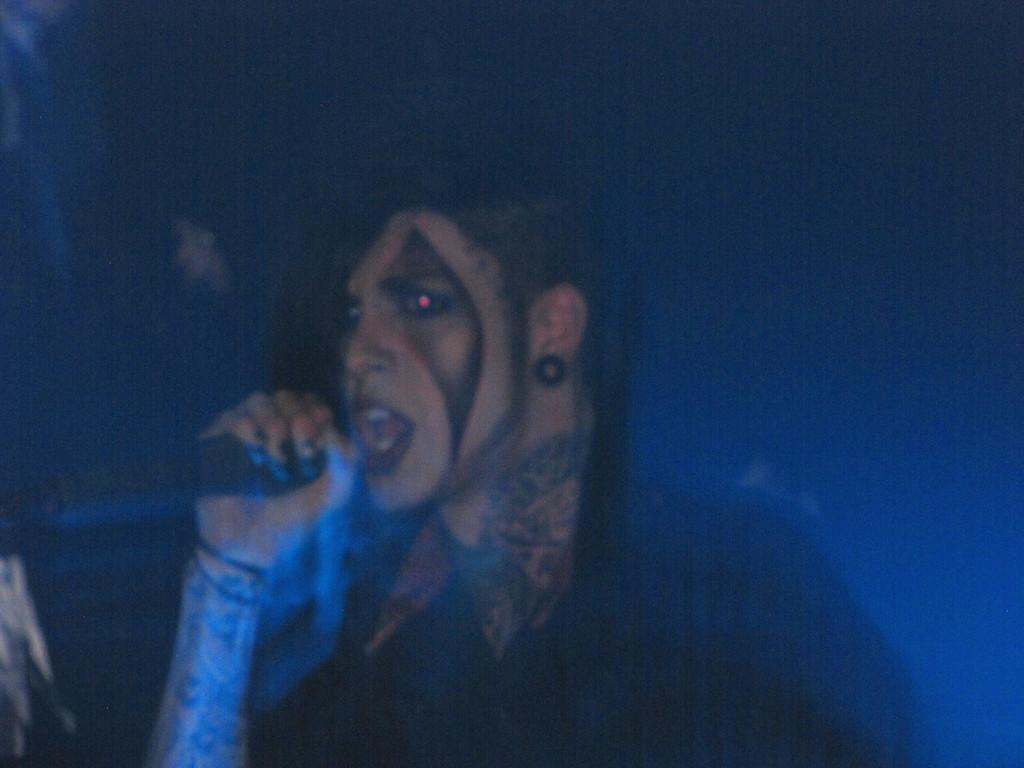What is the overall tone of the image? The image is dark. Can you describe the person in the image? There is a person in the image, and they are holding a microphone. What is the person doing in the image? The person is singing. Which direction is the person facing in the image? The person is facing the left side. What color is the background in the image? The background is black. What message does the queen deliver to the person in the image before they say good-bye? There is no queen or good-bye message present in the image. The person is simply singing while facing the left side. 